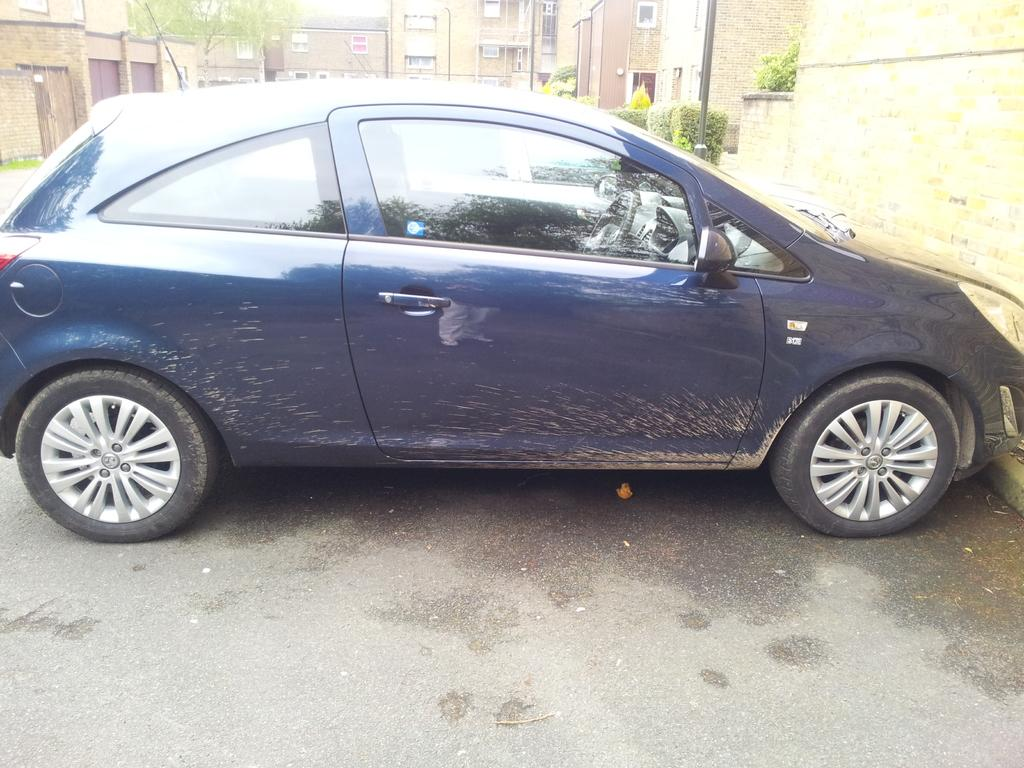What type of vehicle is in the image? There is a car in the image. What is the car's current state? The car is parked. What structures are visible in the image? There are buildings in the image. What type of vegetation can be seen in the image? There are bushes and a tree in the image. What might be the setting of the image? The image likely depicts a road. Where is the crowd gathered in the image? There is no crowd present in the image. What type of system is responsible for the steam in the image? There is no steam present in the image. 